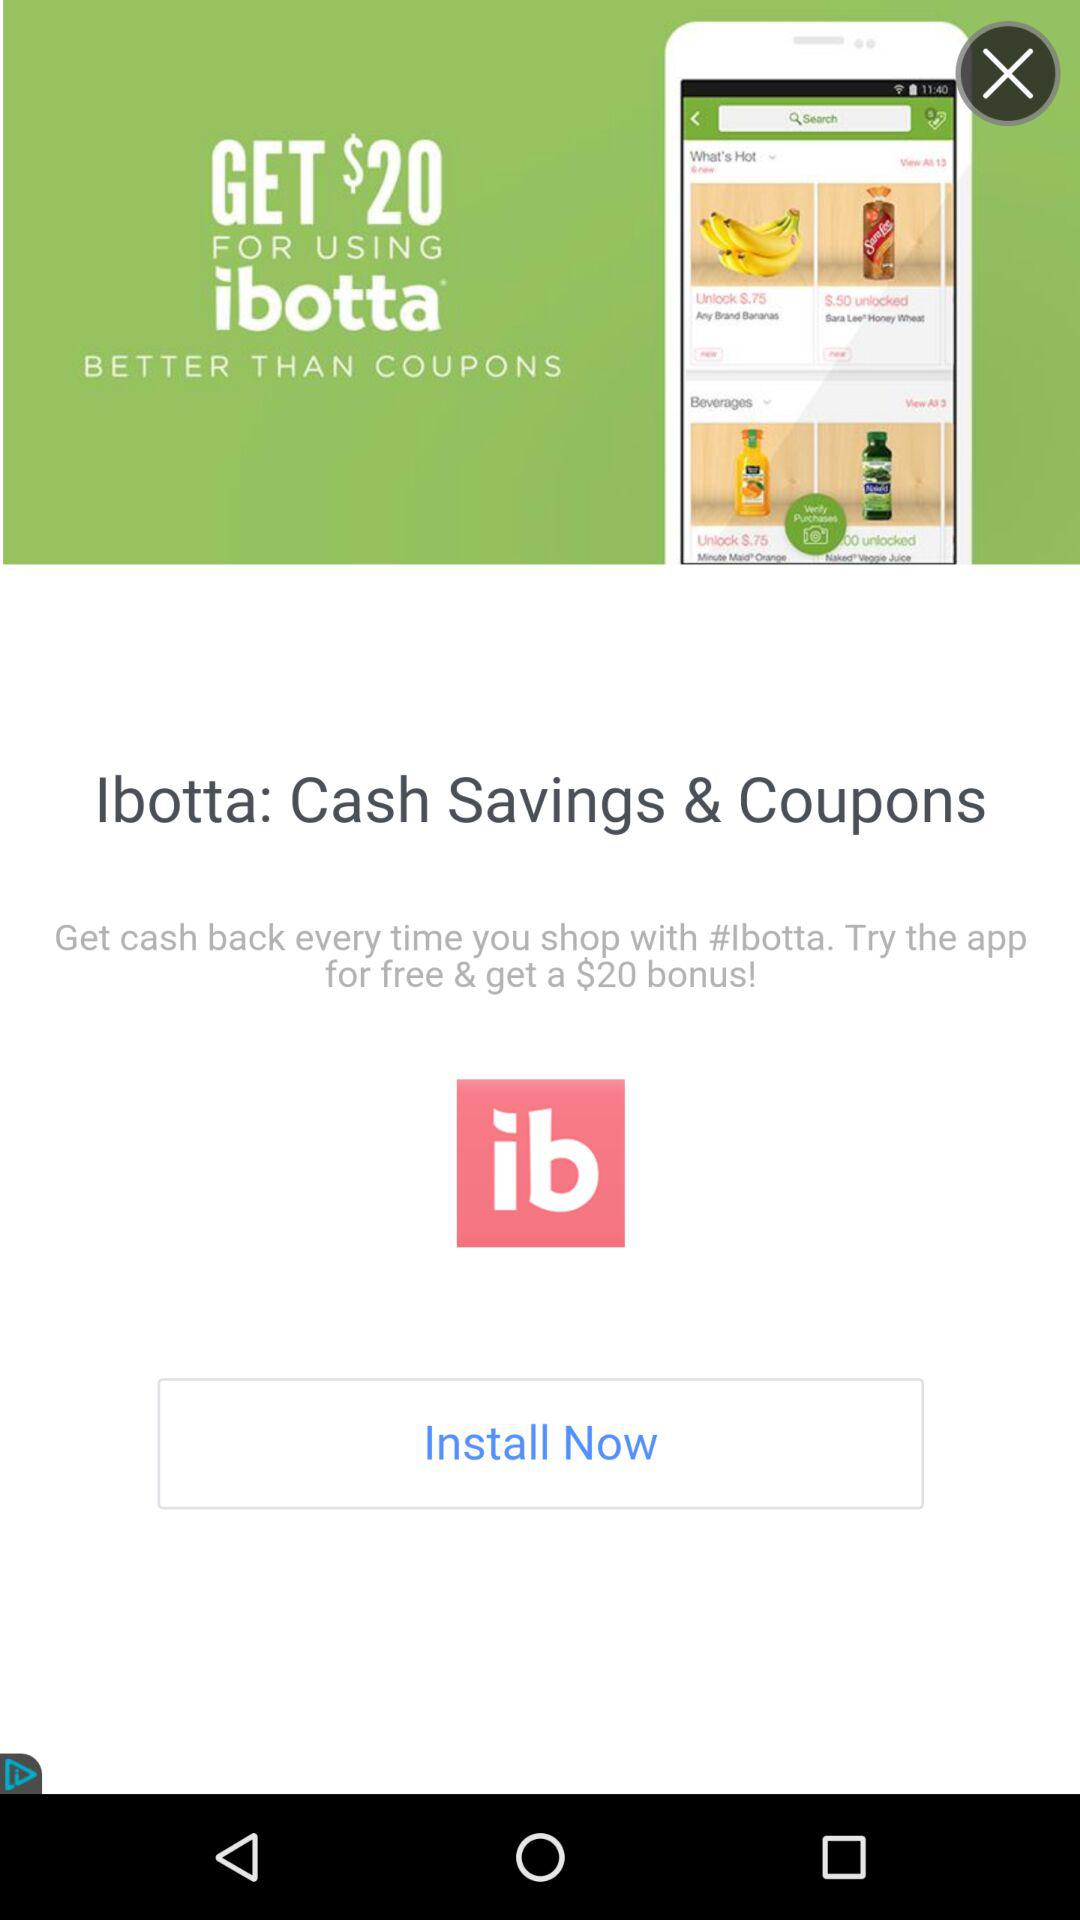How many dollars more is the $20 bonus than the $5 cash back?
Answer the question using a single word or phrase. 15 